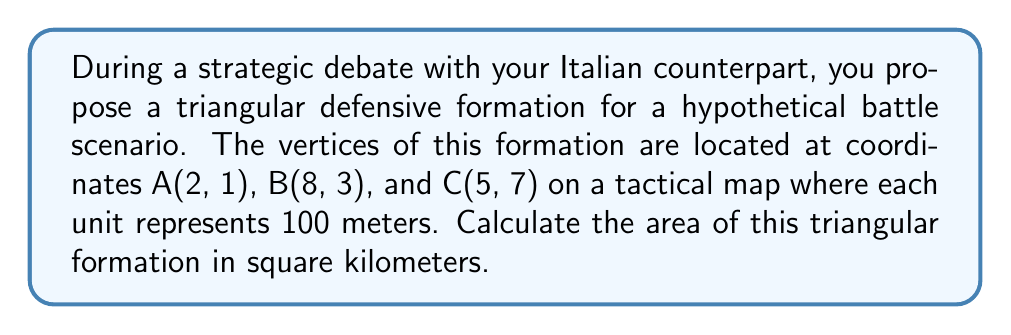Can you answer this question? To solve this problem, we'll use the formula for the area of a triangle given the coordinates of its vertices. The formula is:

$$\text{Area} = \frac{1}{2}|x_1(y_2 - y_3) + x_2(y_3 - y_1) + x_3(y_1 - y_2)|$$

Where $(x_1, y_1)$, $(x_2, y_2)$, and $(x_3, y_3)$ are the coordinates of the three vertices.

Let's substitute the given coordinates:
A(2, 1), B(8, 3), C(5, 7)

$$\begin{align*}
\text{Area} &= \frac{1}{2}|2(3 - 7) + 8(7 - 1) + 5(1 - 3)| \\
&= \frac{1}{2}|2(-4) + 8(6) + 5(-2)| \\
&= \frac{1}{2}|-8 + 48 - 10| \\
&= \frac{1}{2}|30| \\
&= \frac{1}{2} \cdot 30 \\
&= 15 \text{ square units}
\end{align*}$$

Now, we need to convert this to square kilometers. Each unit represents 100 meters, so:

$$\begin{align*}
15 \text{ square units} &= 15 \cdot (100 \text{ m} \times 100 \text{ m}) \\
&= 15 \cdot 10,000 \text{ m}^2 \\
&= 150,000 \text{ m}^2 \\
&= 0.15 \text{ km}^2
\end{align*}$$

[asy]
unitsize(10mm);
draw((2,1)--(8,3)--(5,7)--cycle);
dot((2,1)); dot((8,3)); dot((5,7));
label("A(2,1)", (2,1), SW);
label("B(8,3)", (8,3), SE);
label("C(5,7)", (5,7), N);
[/asy]
Answer: The area of the triangular defensive formation is 0.15 square kilometers. 